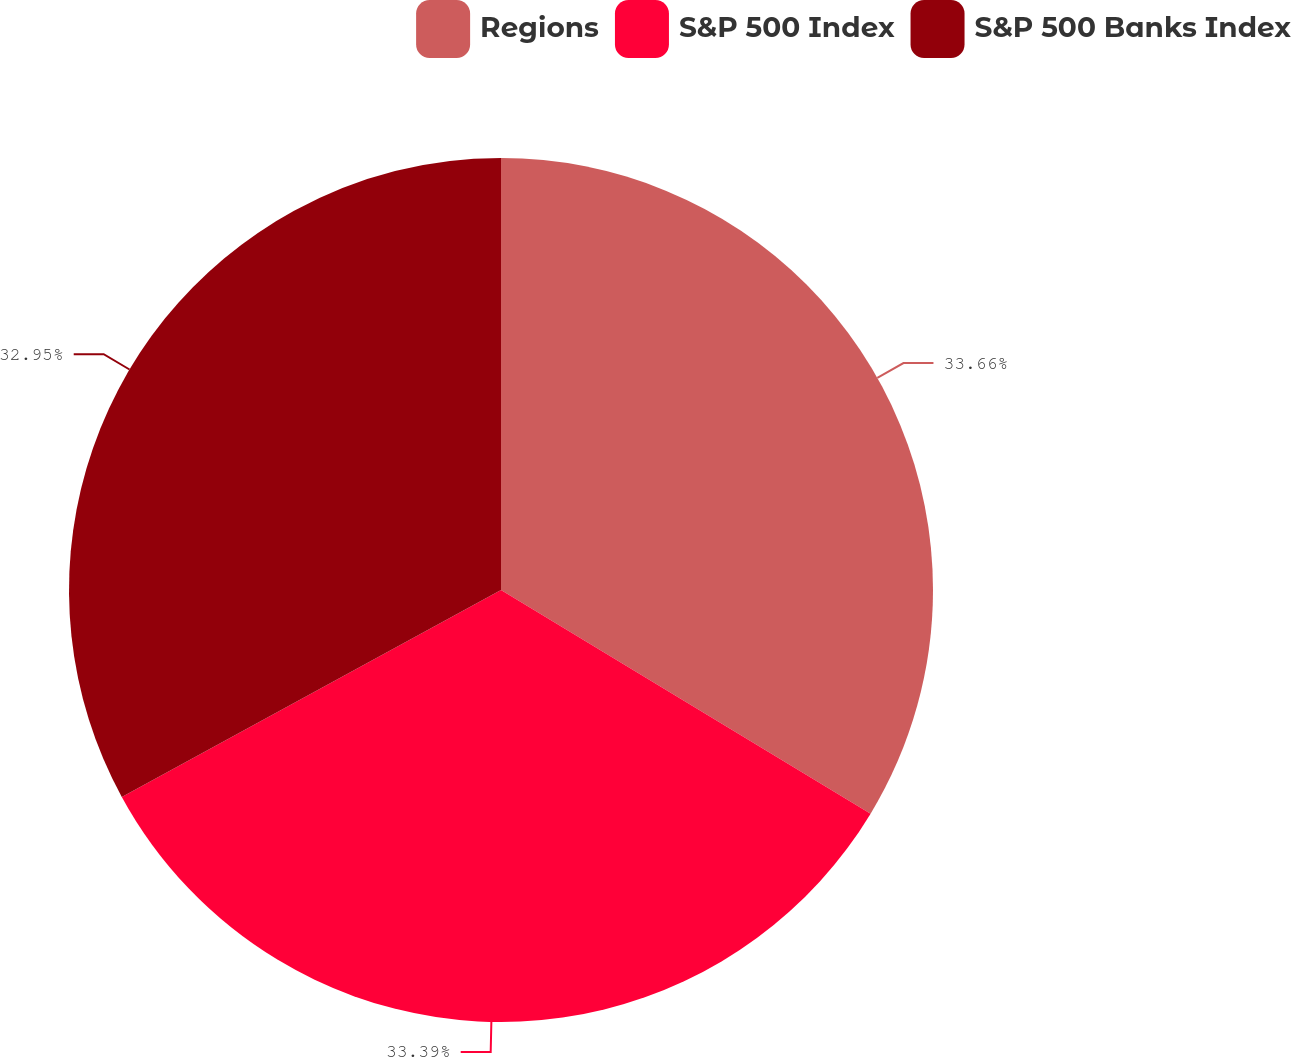Convert chart to OTSL. <chart><loc_0><loc_0><loc_500><loc_500><pie_chart><fcel>Regions<fcel>S&P 500 Index<fcel>S&P 500 Banks Index<nl><fcel>33.66%<fcel>33.39%<fcel>32.95%<nl></chart> 